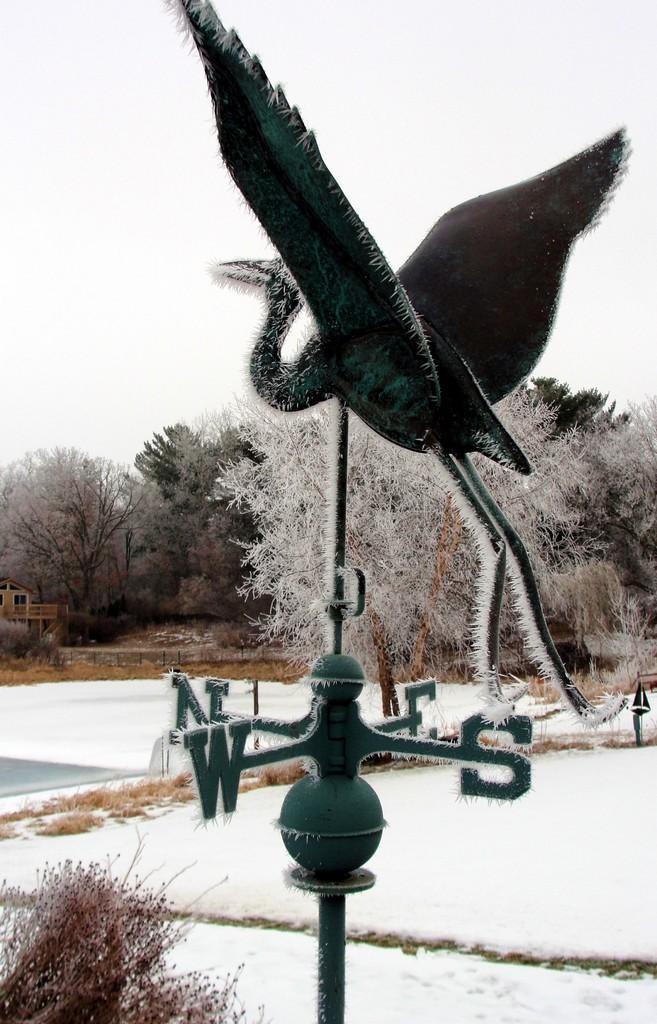How would you summarize this image in a sentence or two? This image is taken outdoors. At the bottom of the image there is a ground covered with snow. In the background there are many trees. In the middle of the image there is a pole with directions and there is an artificial bird. At the top of the image there is a sky. 